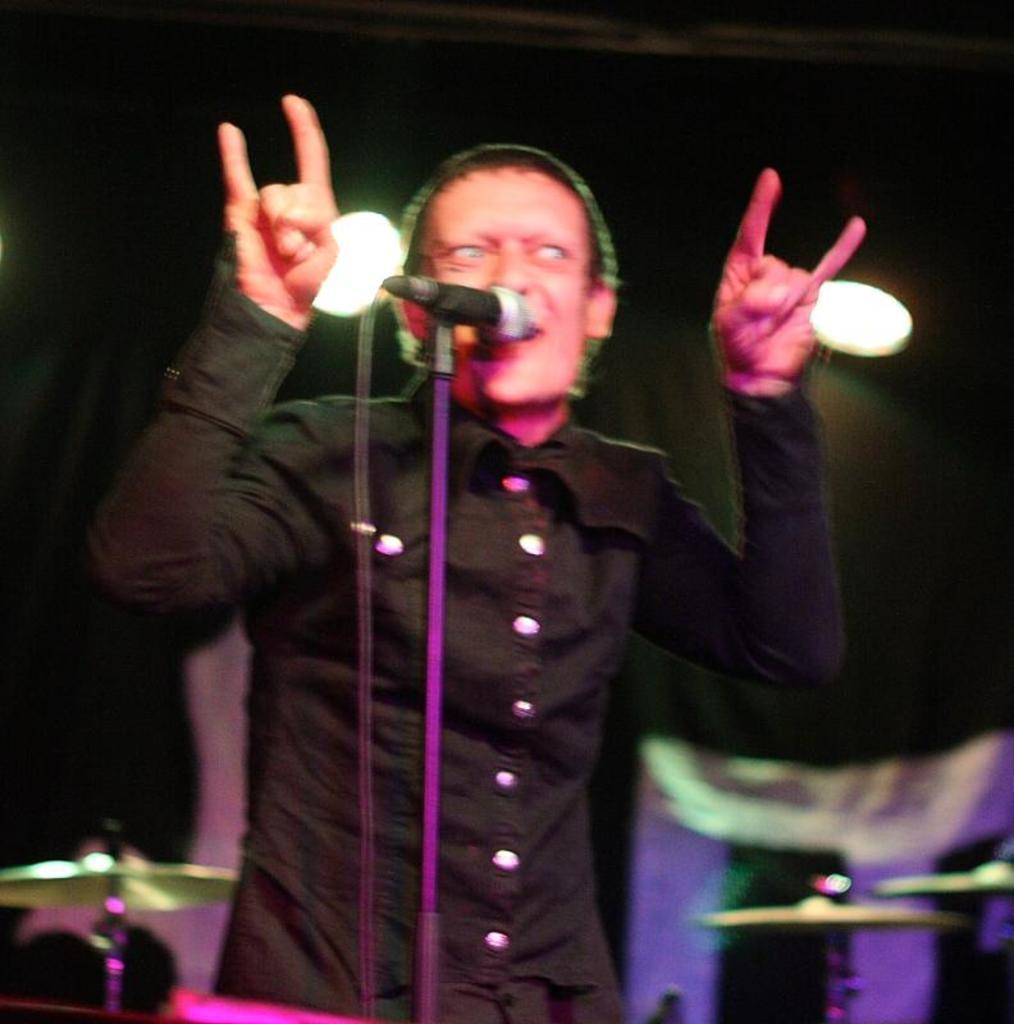Please provide a concise description of this image. In the image there is a man singing on mic,behind him there is drum kit and on the backside wall there are lights. 